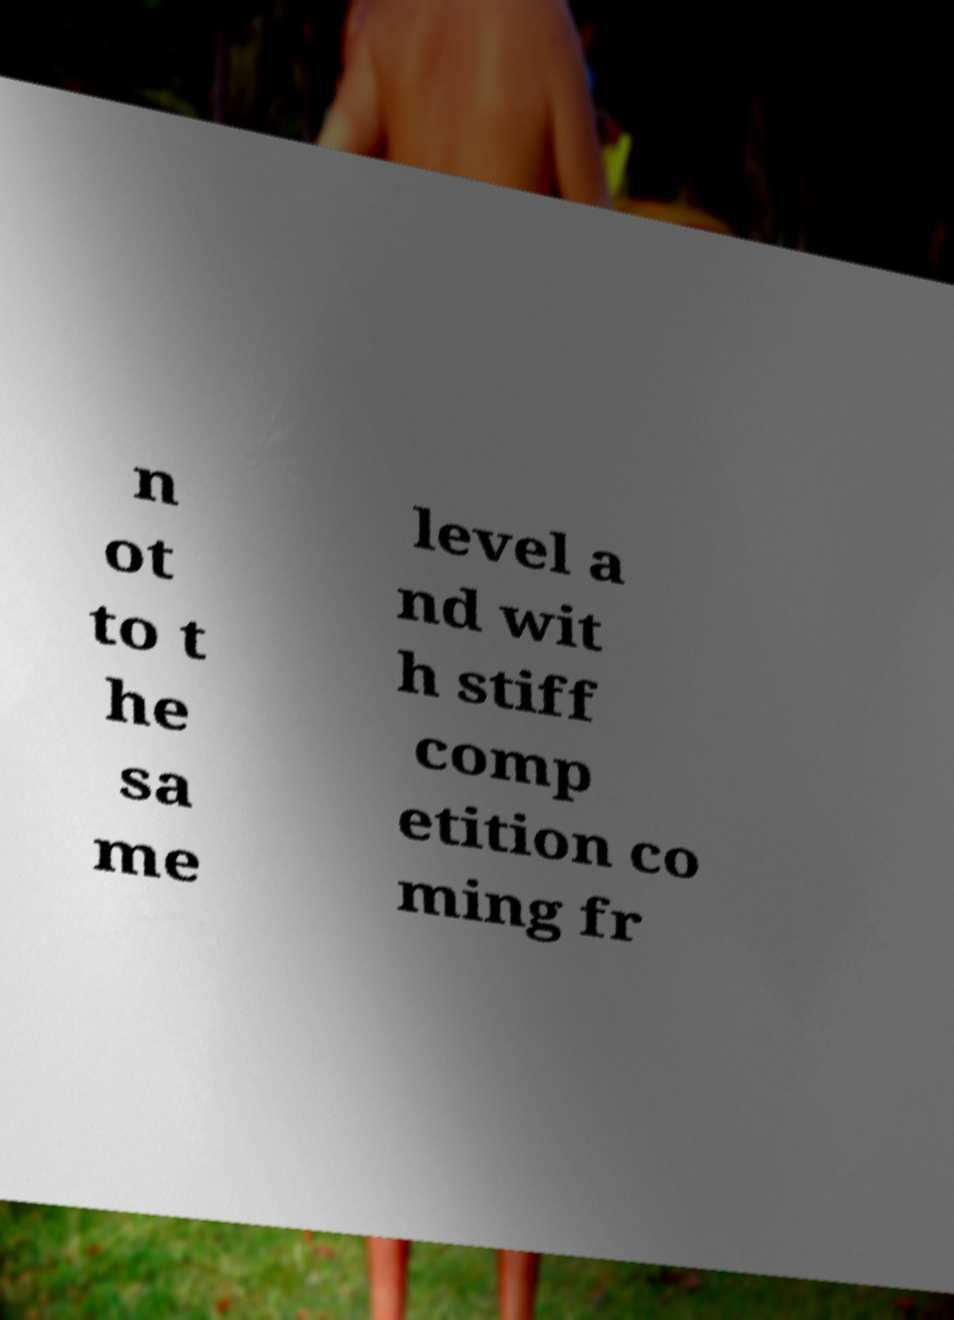For documentation purposes, I need the text within this image transcribed. Could you provide that? n ot to t he sa me level a nd wit h stiff comp etition co ming fr 